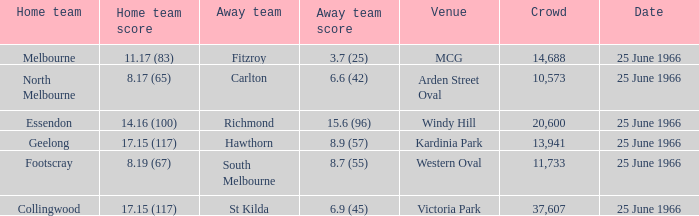When a home team scored 17.15 (117) and the away team scored 6.9 (45), what was the away team? St Kilda. 